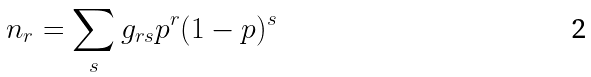<formula> <loc_0><loc_0><loc_500><loc_500>n _ { r } = \sum _ { s } g _ { r s } p ^ { r } ( 1 - p ) ^ { s }</formula> 